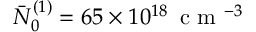<formula> <loc_0><loc_0><loc_500><loc_500>\bar { N } _ { 0 } ^ { ( 1 ) } = 6 5 \times 1 0 ^ { 1 8 } \, c m ^ { - 3 }</formula> 